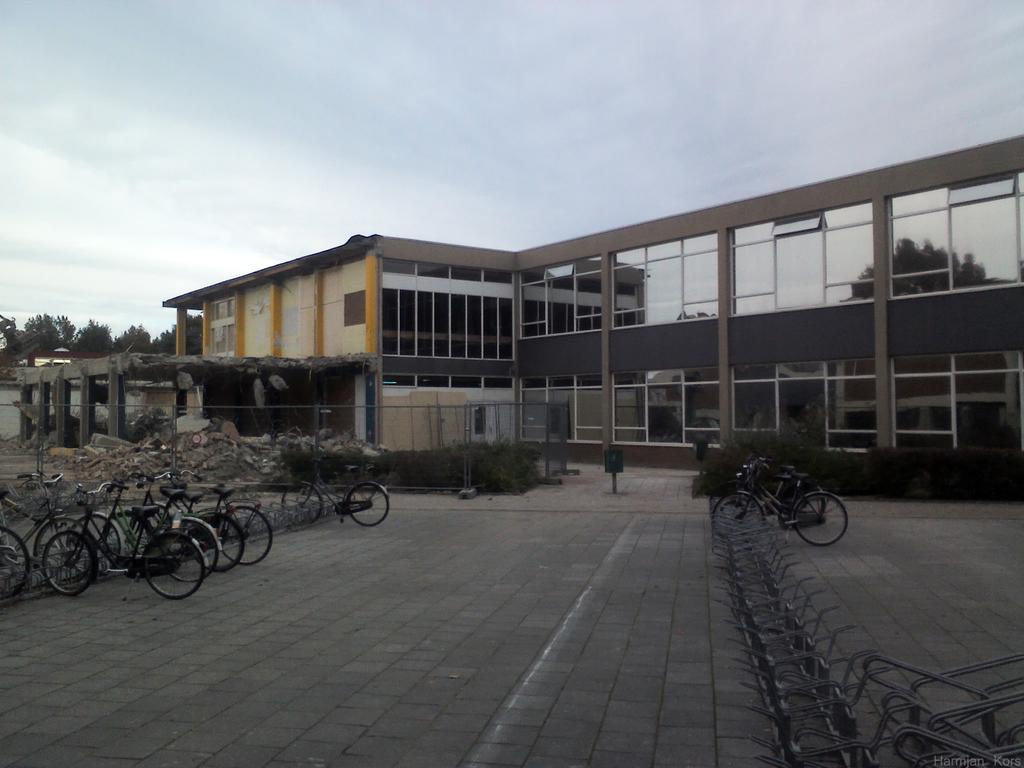Please provide a concise description of this image. In this picture I can see a building and few bicycles parked and I can see trees and I can see metal fence, plants and I can see cloudy sky and I can see dismantled building. 